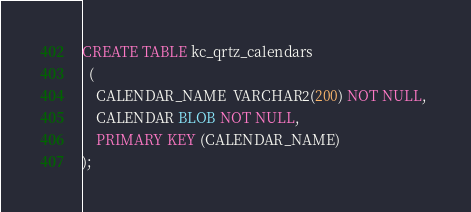Convert code to text. <code><loc_0><loc_0><loc_500><loc_500><_SQL_>CREATE TABLE kc_qrtz_calendars
  (
    CALENDAR_NAME  VARCHAR2(200) NOT NULL, 
    CALENDAR BLOB NOT NULL,
    PRIMARY KEY (CALENDAR_NAME)
);</code> 